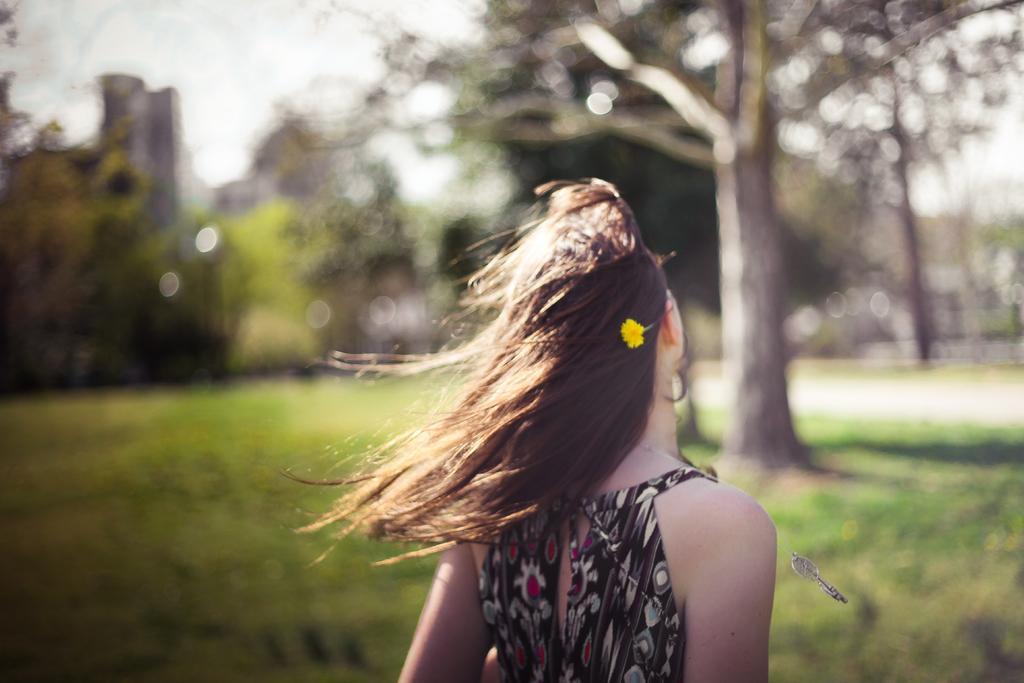Could you give a brief overview of what you see in this image? In this image we can see a lady. In the background there are trees, buildings and sky. At the bottom there is grass. 